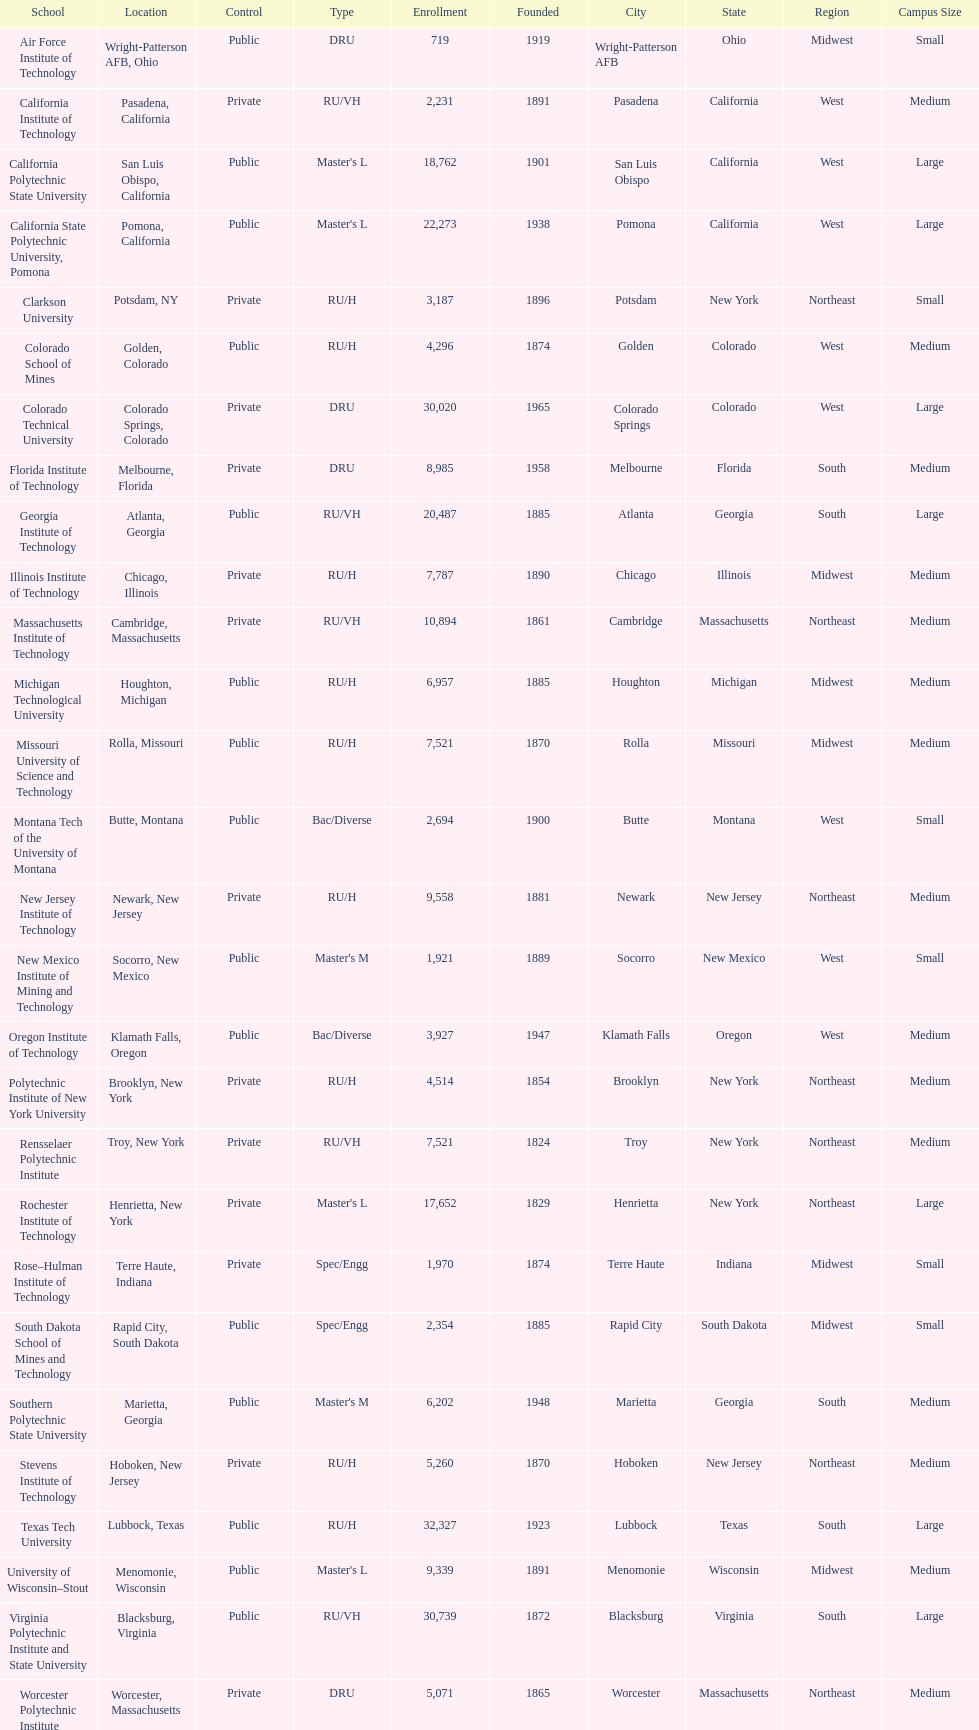What is the difference in enrollment between the top 2 schools listed in the table? 1512. 